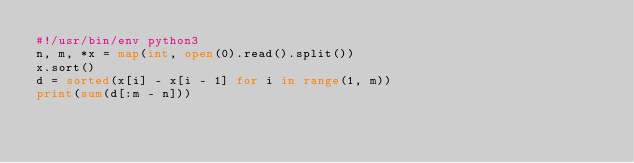<code> <loc_0><loc_0><loc_500><loc_500><_Python_>#!/usr/bin/env python3
n, m, *x = map(int, open(0).read().split())
x.sort()
d = sorted(x[i] - x[i - 1] for i in range(1, m))
print(sum(d[:m - n]))
</code> 